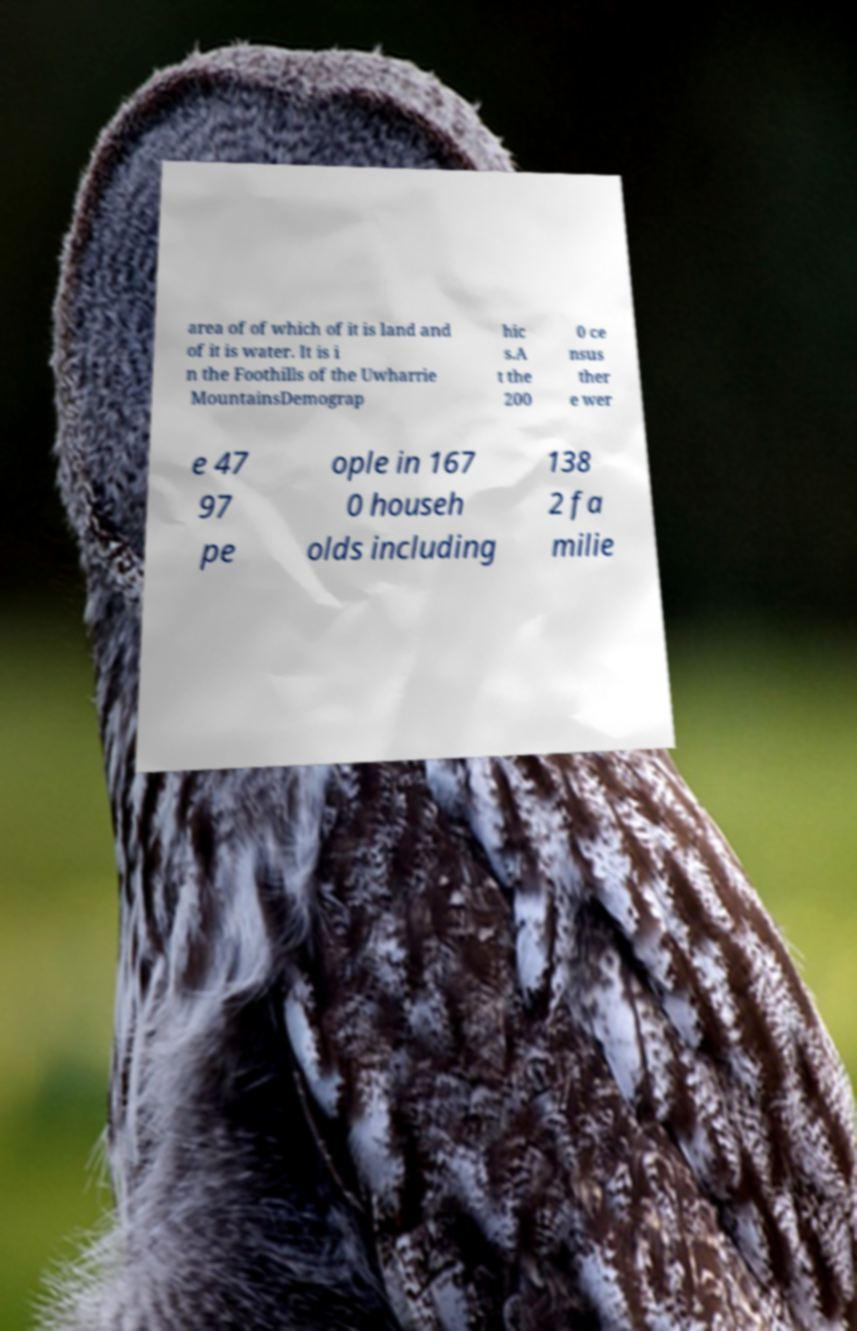Could you extract and type out the text from this image? area of of which of it is land and of it is water. It is i n the Foothills of the Uwharrie MountainsDemograp hic s.A t the 200 0 ce nsus ther e wer e 47 97 pe ople in 167 0 househ olds including 138 2 fa milie 